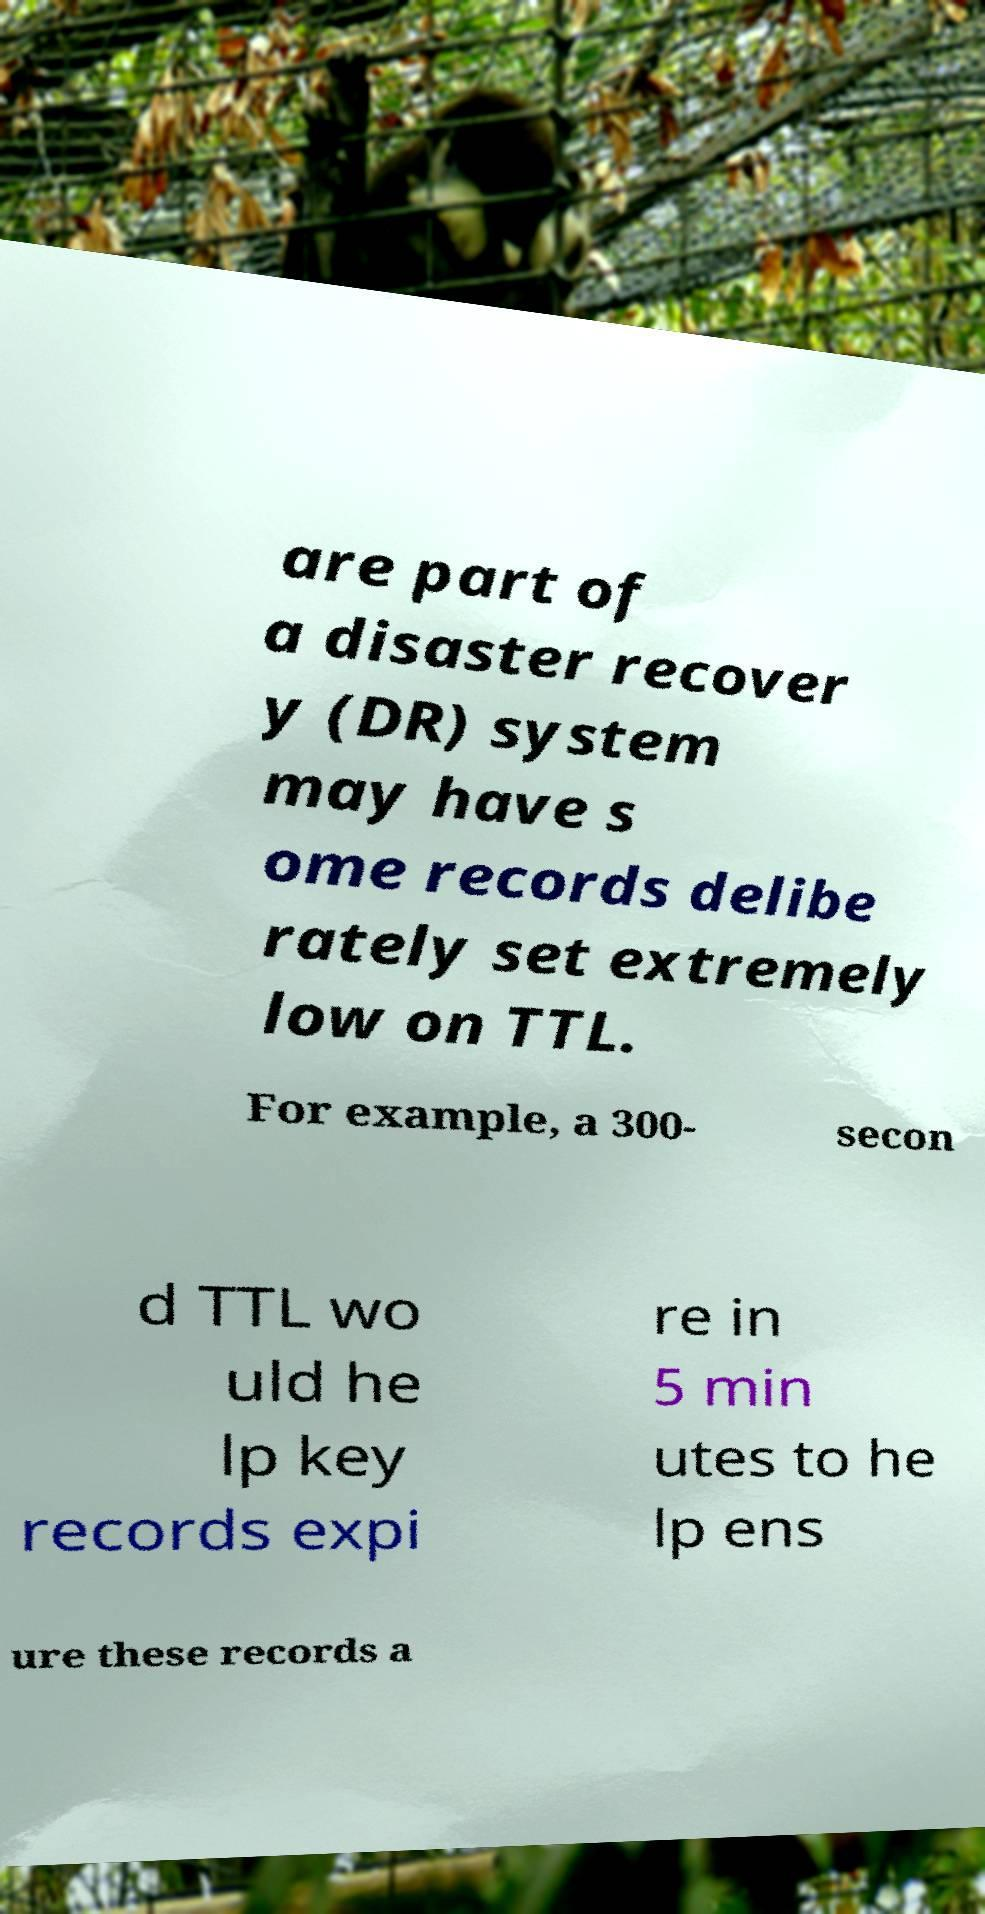Please read and relay the text visible in this image. What does it say? are part of a disaster recover y (DR) system may have s ome records delibe rately set extremely low on TTL. For example, a 300- secon d TTL wo uld he lp key records expi re in 5 min utes to he lp ens ure these records a 